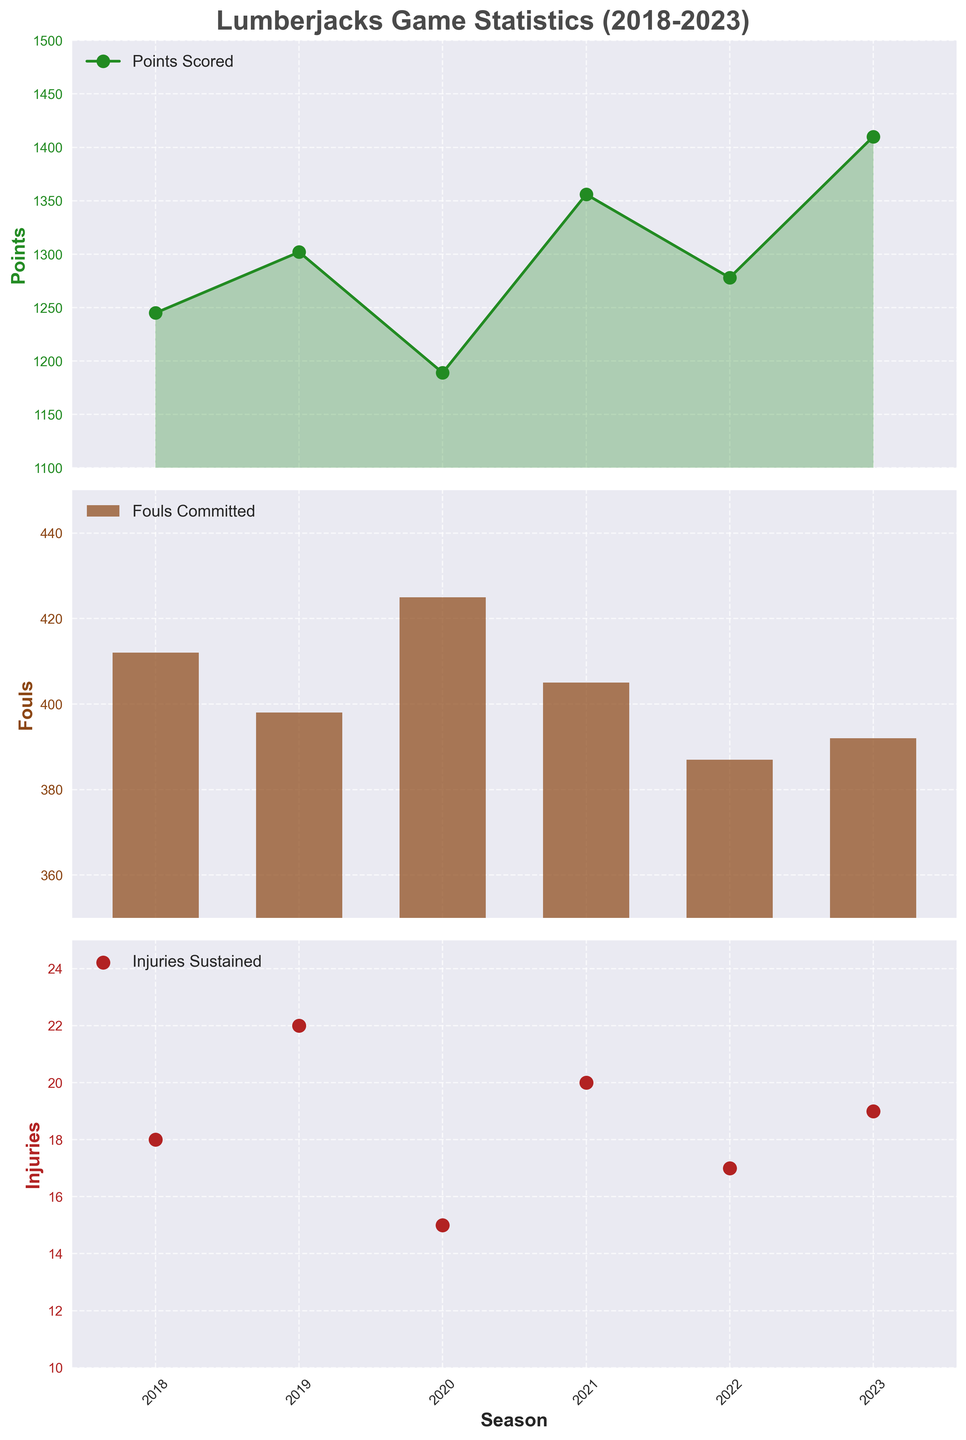what's the color used for the line representing points scored? The color for the line representing points scored is a shade of green, as seen from the line and the fill in the first subplot
Answer: green what's the highest number of points scored in a single season? The highest number of points scored is identified from the highest point on the first subplot. The peak point reaches up to 1410 in the 2023 season
Answer: 1410 compare the fouls committed in 2020 and 2023. Which season had more? By comparing the bars in the second subplot, the fouls committed in 2020 are 425, and in 2023, it's 392. So, 2020 had more fouls
Answer: 2020 calculate the average number of injuries sustained from 2018 to 2023. Sum the injuries from 2018 to 2023 (18+22+15+20+17+19 = 111) and divide by the number of seasons (6). So the average is 111/6 = 18.5
Answer: 18.5 are fouls committed showing an increasing or decreasing trend? By observing the bars in the second subplot, fouls show a fluctuating pattern but overall slightly decrease from 2018 (412) to 2023 (392)
Answer: decreasing which seasons saw an increase in points scored compared to the previous season? Comparing points year over year: 2019 (1302) > 2018 (1245), 2021 (1356) > 2020 (1189), 2023 (1410) > 2022 (1278). So the seasons are 2019, 2021, and 2023
Answer: 2019, 2021, 2023 how many injuries were sustained in 2021 and how does it compare to 2020? In 2021, the number of injuries is 20. In 2020, it was 15. Therefore, 2021 saw an increase of 5 injuries compared to 2020
Answer: 20, increase by 5 what's the label for the y-axis of the first subplot? The first subplot represents points scored, so the y-axis label is 'Points' as shown on the side of the plot
Answer: Points identify the season with the least number of fouls committed. By observing the shortest bar in the second subplot, the 2022 season has the least number of fouls committed at 387
Answer: 2022 examine the trend in injuries sustained between 2018 and 2023. What do you observe? The scatter plot in the third subplot shows injuries sustained fluctuating without a clear trend between 2018 (18) and 2023 (19)
Answer: fluctuating 